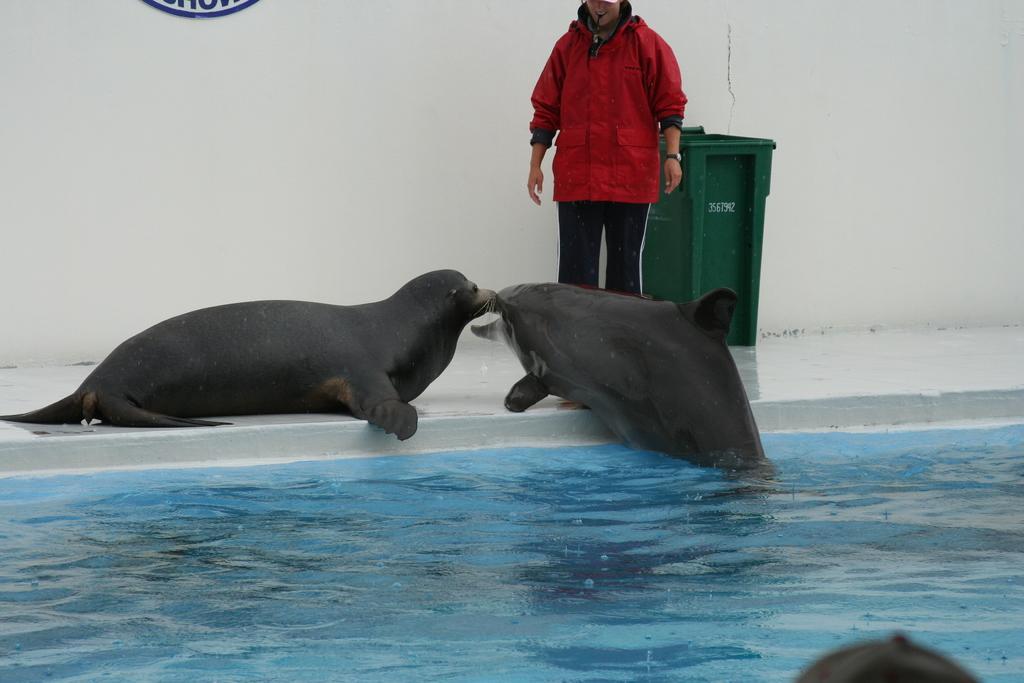Could you give a brief overview of what you see in this image? At the bottom, we see water and this water might be in the swimming pool. Beside that, we see two seals. Beside that, we see a man in the red jacket is standing. Beside him, we see a garbage bin in green color. In the background, we see a white wall. 